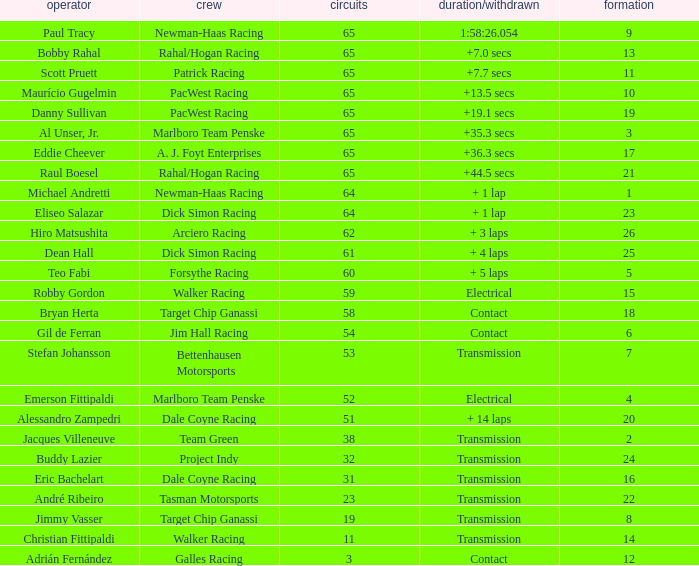What was the highest grid for a time/retired of +19.1 secs? 19.0. 